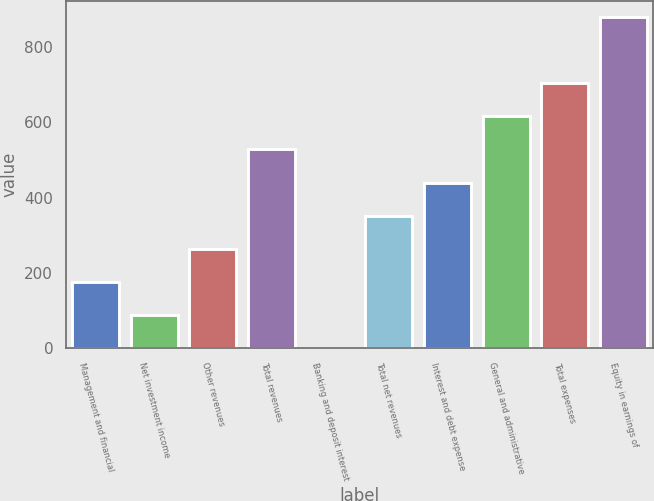Convert chart to OTSL. <chart><loc_0><loc_0><loc_500><loc_500><bar_chart><fcel>Management and financial<fcel>Net investment income<fcel>Other revenues<fcel>Total revenues<fcel>Banking and deposit interest<fcel>Total net revenues<fcel>Interest and debt expense<fcel>General and administrative<fcel>Total expenses<fcel>Equity in earnings of<nl><fcel>176.6<fcel>88.8<fcel>264.4<fcel>527.8<fcel>1<fcel>352.2<fcel>440<fcel>615.6<fcel>703.4<fcel>879<nl></chart> 